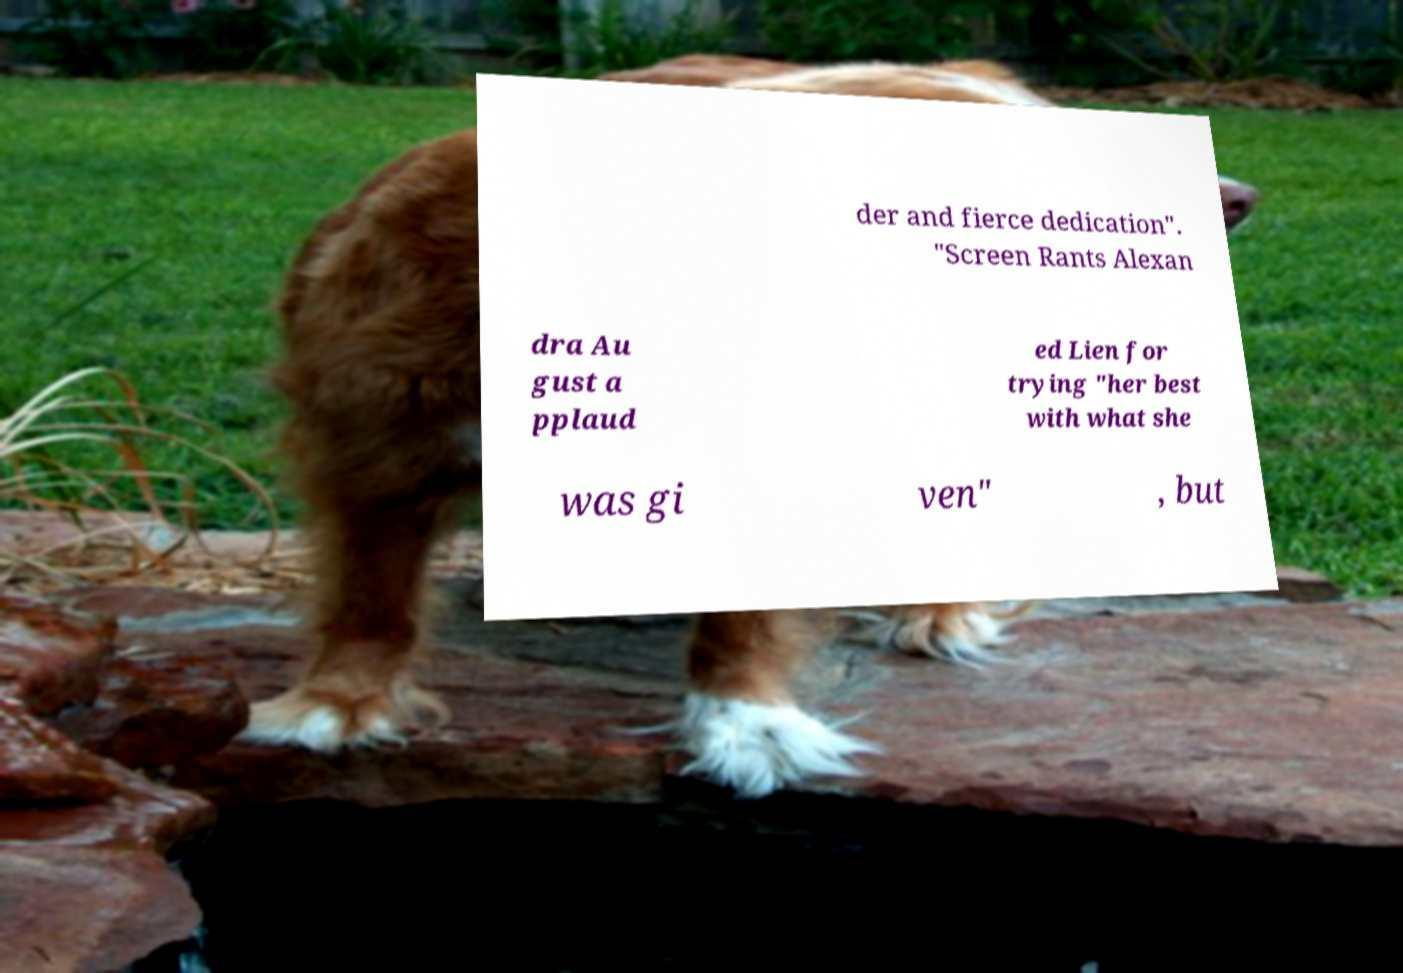Could you assist in decoding the text presented in this image and type it out clearly? der and fierce dedication". "Screen Rants Alexan dra Au gust a pplaud ed Lien for trying "her best with what she was gi ven" , but 